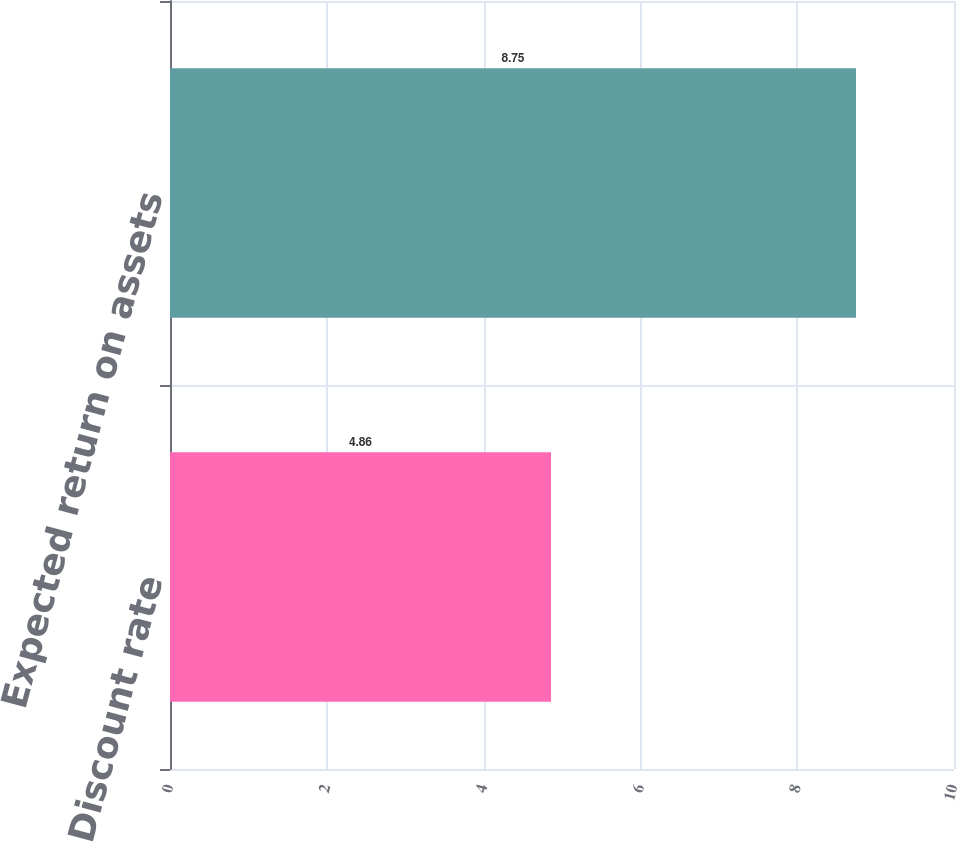Convert chart to OTSL. <chart><loc_0><loc_0><loc_500><loc_500><bar_chart><fcel>Discount rate<fcel>Expected return on assets<nl><fcel>4.86<fcel>8.75<nl></chart> 